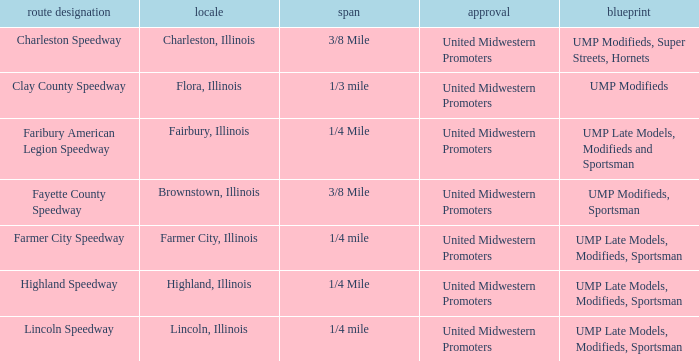What programs were held at highland speedway? UMP Late Models, Modifieds, Sportsman. 